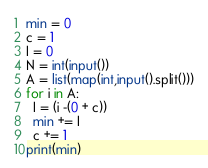<code> <loc_0><loc_0><loc_500><loc_500><_Python_>min = 0
c = 1
I = 0
N = int(input())
A = list(map(int,input().split()))
for i in A:
  I = (i -(0 + c))
  min += I
  c += 1
print(min)</code> 